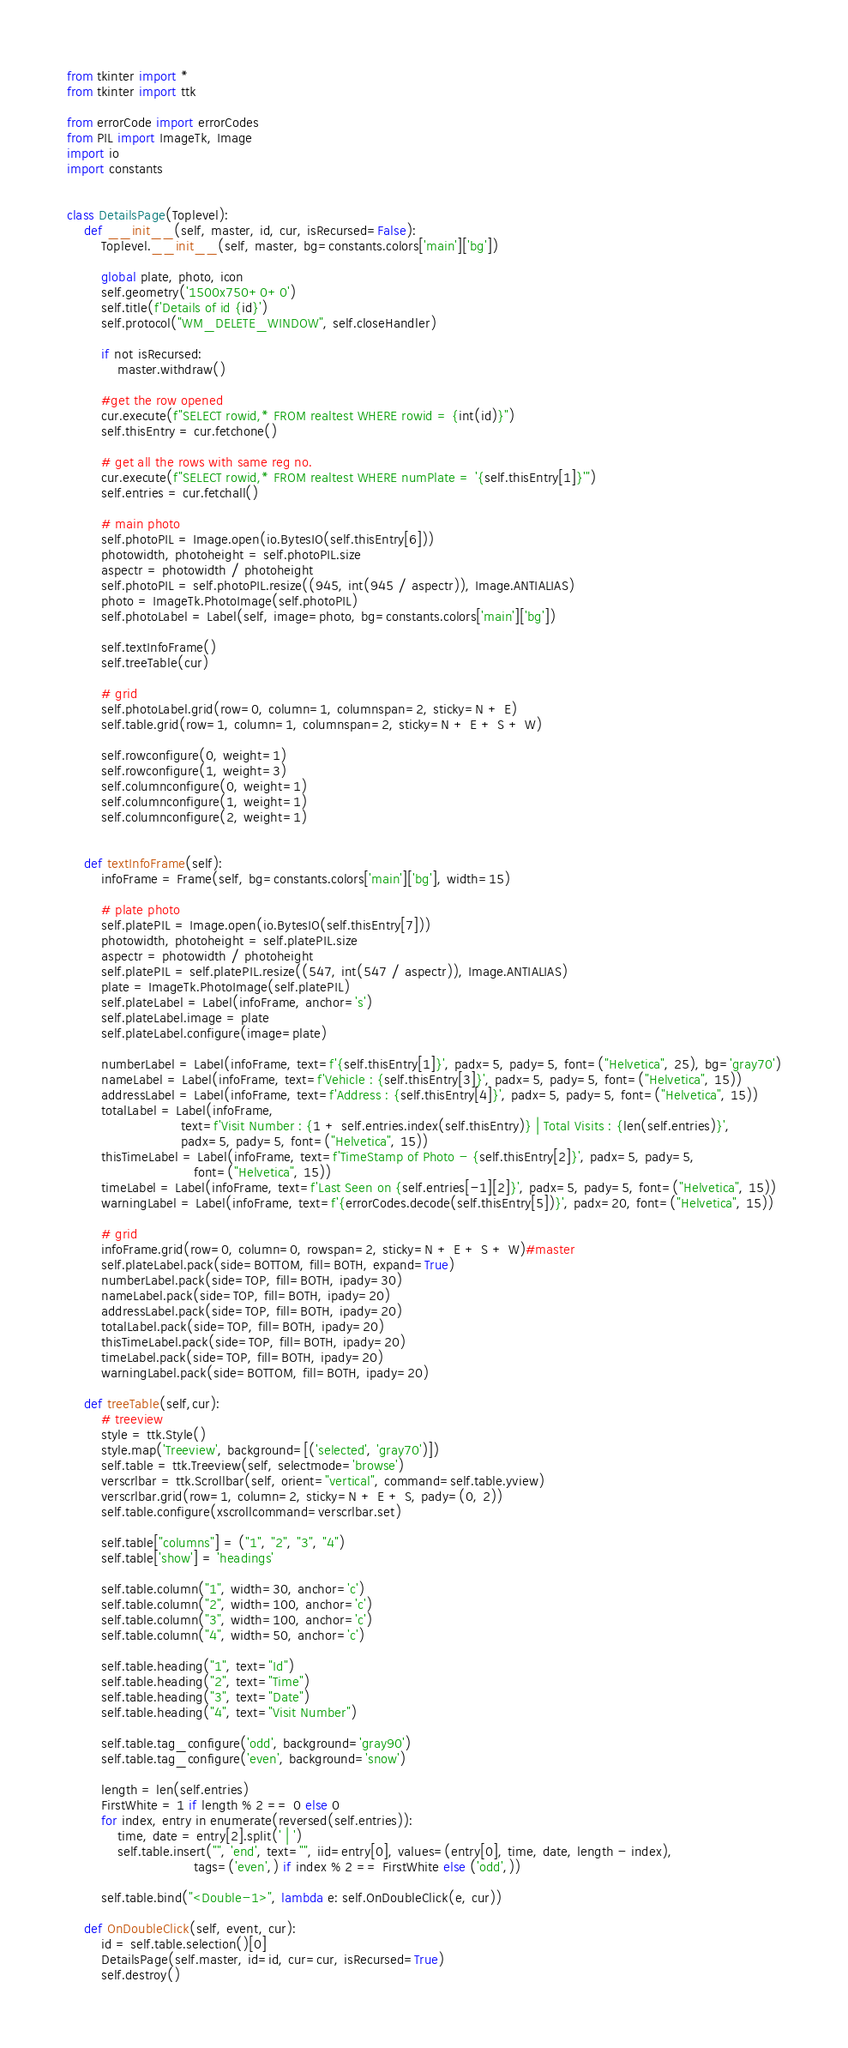Convert code to text. <code><loc_0><loc_0><loc_500><loc_500><_Python_>from tkinter import *
from tkinter import ttk

from errorCode import errorCodes
from PIL import ImageTk, Image
import io
import constants


class DetailsPage(Toplevel):
    def __init__(self, master, id, cur, isRecursed=False):
        Toplevel.__init__(self, master, bg=constants.colors['main']['bg'])

        global plate, photo, icon
        self.geometry('1500x750+0+0')
        self.title(f'Details of id {id}')
        self.protocol("WM_DELETE_WINDOW", self.closeHandler)

        if not isRecursed:
            master.withdraw()

        #get the row opened
        cur.execute(f"SELECT rowid,* FROM realtest WHERE rowid = {int(id)}")
        self.thisEntry = cur.fetchone()

        # get all the rows with same reg no.
        cur.execute(f"SELECT rowid,* FROM realtest WHERE numPlate = '{self.thisEntry[1]}'")
        self.entries = cur.fetchall()

        # main photo
        self.photoPIL = Image.open(io.BytesIO(self.thisEntry[6]))
        photowidth, photoheight = self.photoPIL.size
        aspectr = photowidth / photoheight
        self.photoPIL = self.photoPIL.resize((945, int(945 / aspectr)), Image.ANTIALIAS)
        photo = ImageTk.PhotoImage(self.photoPIL)
        self.photoLabel = Label(self, image=photo, bg=constants.colors['main']['bg'])

        self.textInfoFrame()
        self.treeTable(cur)

        # grid
        self.photoLabel.grid(row=0, column=1, columnspan=2, sticky=N + E)
        self.table.grid(row=1, column=1, columnspan=2, sticky=N + E + S + W)

        self.rowconfigure(0, weight=1)
        self.rowconfigure(1, weight=3)
        self.columnconfigure(0, weight=1)
        self.columnconfigure(1, weight=1)
        self.columnconfigure(2, weight=1)


    def textInfoFrame(self):
        infoFrame = Frame(self, bg=constants.colors['main']['bg'], width=15)

        # plate photo
        self.platePIL = Image.open(io.BytesIO(self.thisEntry[7]))
        photowidth, photoheight = self.platePIL.size
        aspectr = photowidth / photoheight
        self.platePIL = self.platePIL.resize((547, int(547 / aspectr)), Image.ANTIALIAS)
        plate = ImageTk.PhotoImage(self.platePIL)
        self.plateLabel = Label(infoFrame, anchor='s')
        self.plateLabel.image = plate
        self.plateLabel.configure(image=plate)

        numberLabel = Label(infoFrame, text=f'{self.thisEntry[1]}', padx=5, pady=5, font=("Helvetica", 25), bg='gray70')
        nameLabel = Label(infoFrame, text=f'Vehicle : {self.thisEntry[3]}', padx=5, pady=5, font=("Helvetica", 15))
        addressLabel = Label(infoFrame, text=f'Address : {self.thisEntry[4]}', padx=5, pady=5, font=("Helvetica", 15))
        totalLabel = Label(infoFrame,
                           text=f'Visit Number : {1 + self.entries.index(self.thisEntry)} | Total Visits : {len(self.entries)}',
                           padx=5, pady=5, font=("Helvetica", 15))
        thisTimeLabel = Label(infoFrame, text=f'TimeStamp of Photo - {self.thisEntry[2]}', padx=5, pady=5,
                              font=("Helvetica", 15))
        timeLabel = Label(infoFrame, text=f'Last Seen on {self.entries[-1][2]}', padx=5, pady=5, font=("Helvetica", 15))
        warningLabel = Label(infoFrame, text=f'{errorCodes.decode(self.thisEntry[5])}', padx=20, font=("Helvetica", 15))

        # grid
        infoFrame.grid(row=0, column=0, rowspan=2, sticky=N + E + S + W)#master
        self.plateLabel.pack(side=BOTTOM, fill=BOTH, expand=True)
        numberLabel.pack(side=TOP, fill=BOTH, ipady=30)
        nameLabel.pack(side=TOP, fill=BOTH, ipady=20)
        addressLabel.pack(side=TOP, fill=BOTH, ipady=20)
        totalLabel.pack(side=TOP, fill=BOTH, ipady=20)
        thisTimeLabel.pack(side=TOP, fill=BOTH, ipady=20)
        timeLabel.pack(side=TOP, fill=BOTH, ipady=20)
        warningLabel.pack(side=BOTTOM, fill=BOTH, ipady=20)

    def treeTable(self,cur):
        # treeview
        style = ttk.Style()
        style.map('Treeview', background=[('selected', 'gray70')])
        self.table = ttk.Treeview(self, selectmode='browse')
        verscrlbar = ttk.Scrollbar(self, orient="vertical", command=self.table.yview)
        verscrlbar.grid(row=1, column=2, sticky=N + E + S, pady=(0, 2))
        self.table.configure(xscrollcommand=verscrlbar.set)

        self.table["columns"] = ("1", "2", "3", "4")
        self.table['show'] = 'headings'

        self.table.column("1", width=30, anchor='c')
        self.table.column("2", width=100, anchor='c')
        self.table.column("3", width=100, anchor='c')
        self.table.column("4", width=50, anchor='c')

        self.table.heading("1", text="Id")
        self.table.heading("2", text="Time")
        self.table.heading("3", text="Date")
        self.table.heading("4", text="Visit Number")

        self.table.tag_configure('odd', background='gray90')
        self.table.tag_configure('even', background='snow')

        length = len(self.entries)
        FirstWhite = 1 if length % 2 == 0 else 0
        for index, entry in enumerate(reversed(self.entries)):
            time, date = entry[2].split(' | ')
            self.table.insert("", 'end', text="", iid=entry[0], values=(entry[0], time, date, length - index),
                              tags=('even',) if index % 2 == FirstWhite else ('odd',))

        self.table.bind("<Double-1>", lambda e: self.OnDoubleClick(e, cur))

    def OnDoubleClick(self, event, cur):
        id = self.table.selection()[0]
        DetailsPage(self.master, id=id, cur=cur, isRecursed=True)
        self.destroy()
</code> 